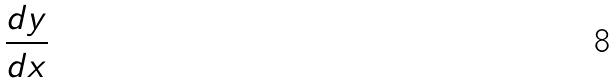<formula> <loc_0><loc_0><loc_500><loc_500>\frac { d y } { d x }</formula> 